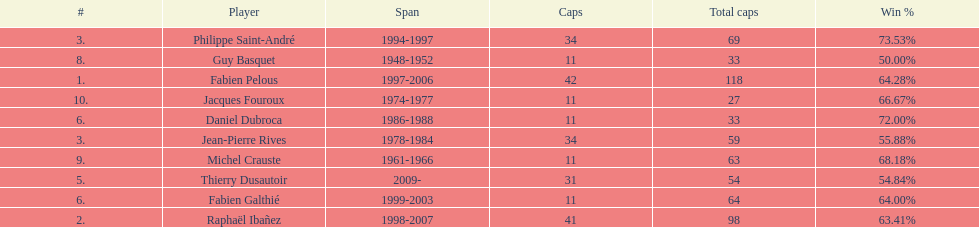Which captain served the least amount of time? Daniel Dubroca. 